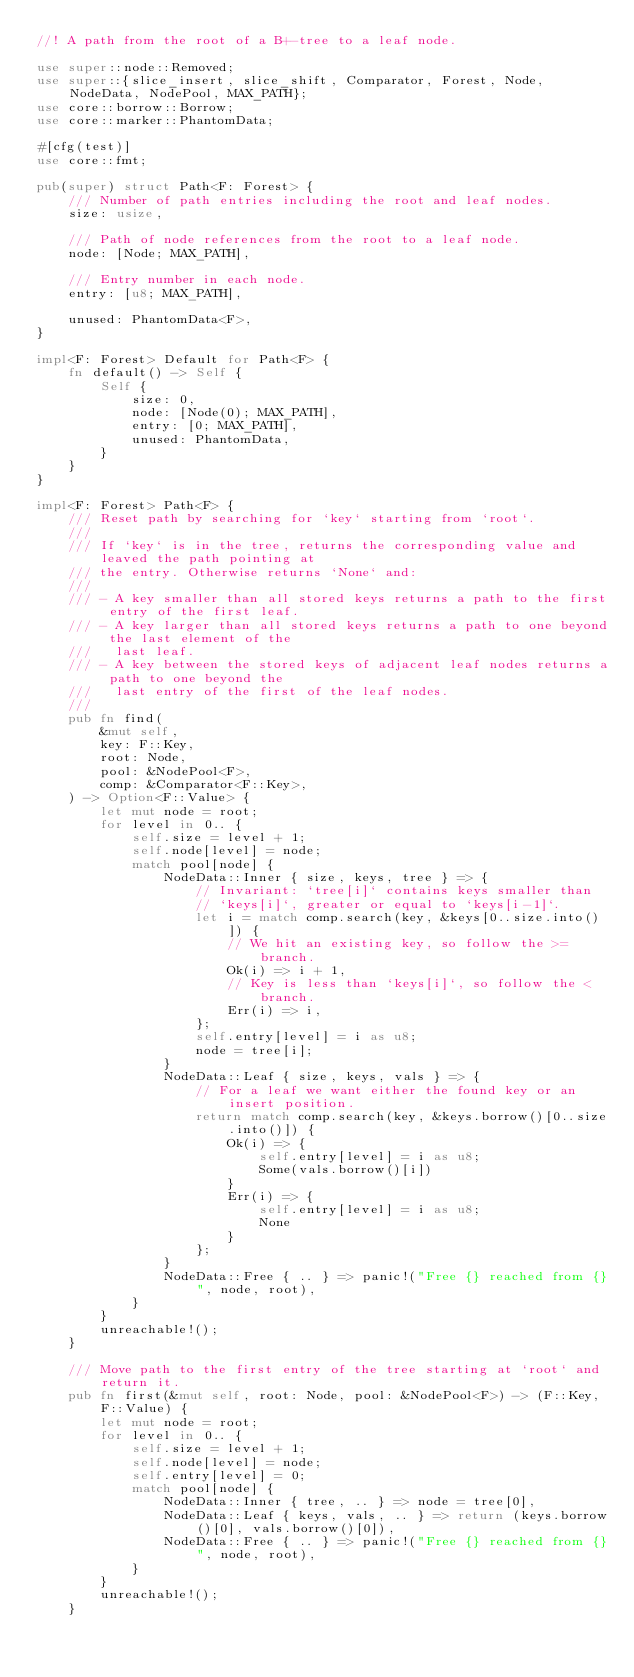<code> <loc_0><loc_0><loc_500><loc_500><_Rust_>//! A path from the root of a B+-tree to a leaf node.

use super::node::Removed;
use super::{slice_insert, slice_shift, Comparator, Forest, Node, NodeData, NodePool, MAX_PATH};
use core::borrow::Borrow;
use core::marker::PhantomData;

#[cfg(test)]
use core::fmt;

pub(super) struct Path<F: Forest> {
    /// Number of path entries including the root and leaf nodes.
    size: usize,

    /// Path of node references from the root to a leaf node.
    node: [Node; MAX_PATH],

    /// Entry number in each node.
    entry: [u8; MAX_PATH],

    unused: PhantomData<F>,
}

impl<F: Forest> Default for Path<F> {
    fn default() -> Self {
        Self {
            size: 0,
            node: [Node(0); MAX_PATH],
            entry: [0; MAX_PATH],
            unused: PhantomData,
        }
    }
}

impl<F: Forest> Path<F> {
    /// Reset path by searching for `key` starting from `root`.
    ///
    /// If `key` is in the tree, returns the corresponding value and leaved the path pointing at
    /// the entry. Otherwise returns `None` and:
    ///
    /// - A key smaller than all stored keys returns a path to the first entry of the first leaf.
    /// - A key larger than all stored keys returns a path to one beyond the last element of the
    ///   last leaf.
    /// - A key between the stored keys of adjacent leaf nodes returns a path to one beyond the
    ///   last entry of the first of the leaf nodes.
    ///
    pub fn find(
        &mut self,
        key: F::Key,
        root: Node,
        pool: &NodePool<F>,
        comp: &Comparator<F::Key>,
    ) -> Option<F::Value> {
        let mut node = root;
        for level in 0.. {
            self.size = level + 1;
            self.node[level] = node;
            match pool[node] {
                NodeData::Inner { size, keys, tree } => {
                    // Invariant: `tree[i]` contains keys smaller than
                    // `keys[i]`, greater or equal to `keys[i-1]`.
                    let i = match comp.search(key, &keys[0..size.into()]) {
                        // We hit an existing key, so follow the >= branch.
                        Ok(i) => i + 1,
                        // Key is less than `keys[i]`, so follow the < branch.
                        Err(i) => i,
                    };
                    self.entry[level] = i as u8;
                    node = tree[i];
                }
                NodeData::Leaf { size, keys, vals } => {
                    // For a leaf we want either the found key or an insert position.
                    return match comp.search(key, &keys.borrow()[0..size.into()]) {
                        Ok(i) => {
                            self.entry[level] = i as u8;
                            Some(vals.borrow()[i])
                        }
                        Err(i) => {
                            self.entry[level] = i as u8;
                            None
                        }
                    };
                }
                NodeData::Free { .. } => panic!("Free {} reached from {}", node, root),
            }
        }
        unreachable!();
    }

    /// Move path to the first entry of the tree starting at `root` and return it.
    pub fn first(&mut self, root: Node, pool: &NodePool<F>) -> (F::Key, F::Value) {
        let mut node = root;
        for level in 0.. {
            self.size = level + 1;
            self.node[level] = node;
            self.entry[level] = 0;
            match pool[node] {
                NodeData::Inner { tree, .. } => node = tree[0],
                NodeData::Leaf { keys, vals, .. } => return (keys.borrow()[0], vals.borrow()[0]),
                NodeData::Free { .. } => panic!("Free {} reached from {}", node, root),
            }
        }
        unreachable!();
    }
</code> 